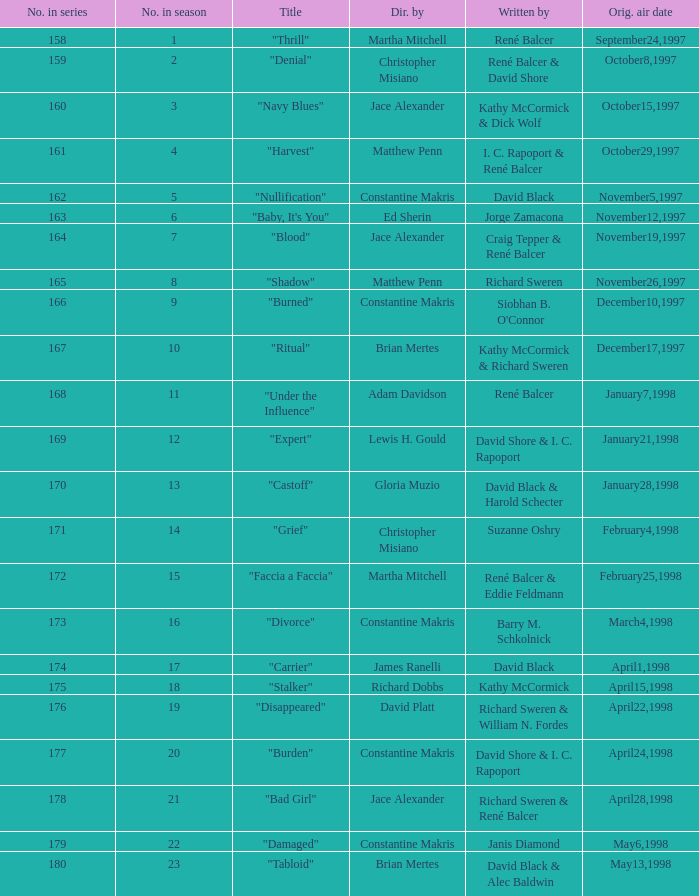Name the title of the episode that ed sherin directed. "Baby, It's You". 